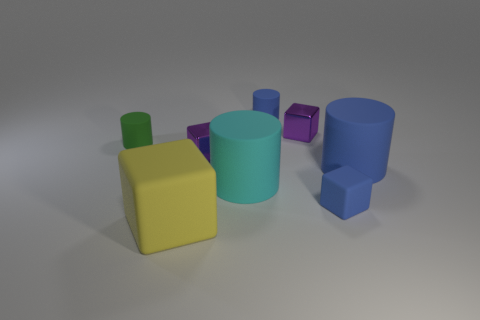There is a blue matte object that is the same size as the cyan cylinder; what shape is it?
Make the answer very short. Cylinder. There is a purple shiny thing in front of the tiny green thing; is its size the same as the cylinder that is behind the green rubber thing?
Your answer should be compact. Yes. What is the color of the large cube that is made of the same material as the green cylinder?
Keep it short and to the point. Yellow. Is the cylinder that is on the left side of the cyan rubber object made of the same material as the purple cube that is in front of the green rubber cylinder?
Your answer should be compact. No. Are there any blocks that have the same size as the yellow thing?
Your answer should be very brief. No. There is a blue cylinder behind the large blue rubber cylinder that is behind the cyan cylinder; how big is it?
Keep it short and to the point. Small. How many rubber cylinders have the same color as the tiny matte block?
Ensure brevity in your answer.  2. There is a tiny blue matte object behind the rubber block that is to the right of the big matte cube; what is its shape?
Give a very brief answer. Cylinder. What number of cyan things have the same material as the tiny green cylinder?
Your answer should be compact. 1. What is the material of the small cylinder right of the yellow matte thing?
Provide a succinct answer. Rubber. 